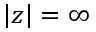Convert formula to latex. <formula><loc_0><loc_0><loc_500><loc_500>| z | = \infty</formula> 